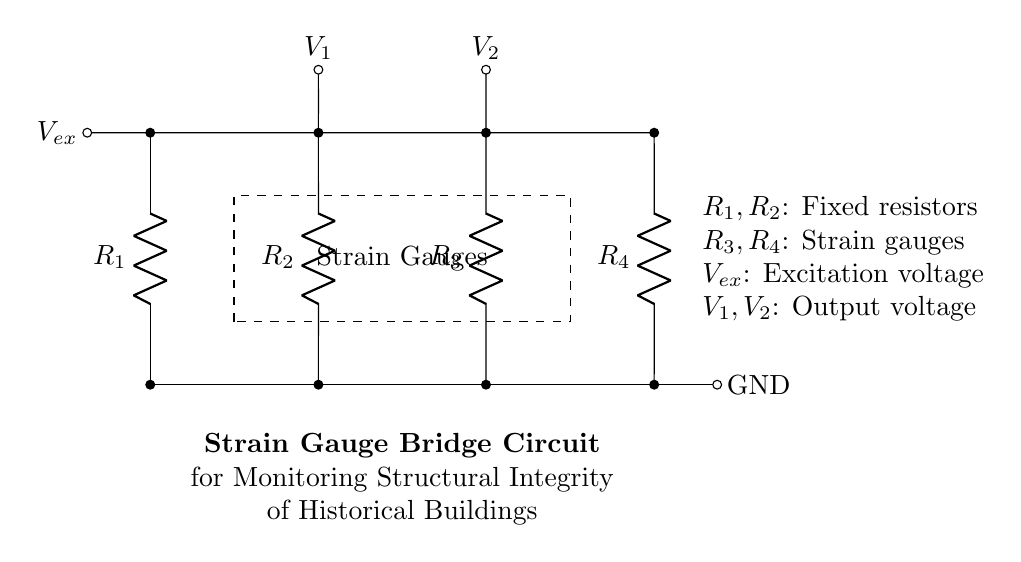What are the types of resistors used in this circuit? The circuit uses two fixed resistors (R1 and R2) and two strain gauges (R3 and R4). This can be determined by examining the labels on the components within the circuit.
Answer: fixed resistors and strain gauges What is the purpose of the excitation voltage? The excitation voltage (Vex) provides the necessary power for the strain gauges to operate. It helps in measuring the resistance change in the strain gauges, which correlates to the amount of strain experienced.
Answer: power for strain gauges How many outputs are there in this circuit? The circuit has two output voltages (V1 and V2) indicated on the diagram. These outputs are the voltage readings taken across the strain gauges.
Answer: two What are the components contained in the strain gauge section of the diagram? The dashed rectangle labeled "Strain Gauges" indicates that R3 and R4 are the components within this section. This visualization helps to segregate the strain gauges from the rest of the circuit.
Answer: R3 and R4 What is the configuration type of this circuit? The circuit is configured as a bridge because it shows a balanced arrangement of resistors, specifically suited for measuring small changes in resistance, which is typical for strain gauge applications.
Answer: bridge configuration How would you describe the functioning principle of this strain gauge bridge circuit? The circuit functions by measuring the voltage difference between V1 and V2 as a result of changes in resistance from the strain gauges when they detect strain. This allows for precise monitoring of structural integrity changes.
Answer: measures voltage difference What represents the ground in this circuit? In the diagram, ground is represented by the GND label at the bottom right, connected to one side of the bridge circuit, which completes the electrical circuit for reference potential.
Answer: GND 